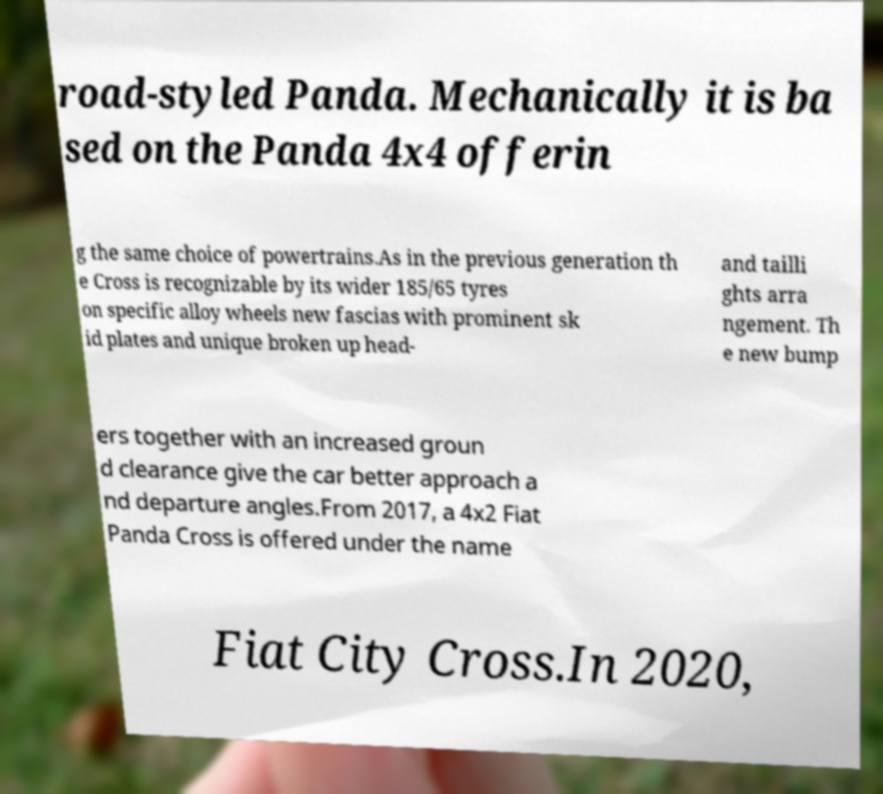What messages or text are displayed in this image? I need them in a readable, typed format. road-styled Panda. Mechanically it is ba sed on the Panda 4x4 offerin g the same choice of powertrains.As in the previous generation th e Cross is recognizable by its wider 185/65 tyres on specific alloy wheels new fascias with prominent sk id plates and unique broken up head- and tailli ghts arra ngement. Th e new bump ers together with an increased groun d clearance give the car better approach a nd departure angles.From 2017, a 4x2 Fiat Panda Cross is offered under the name Fiat City Cross.In 2020, 